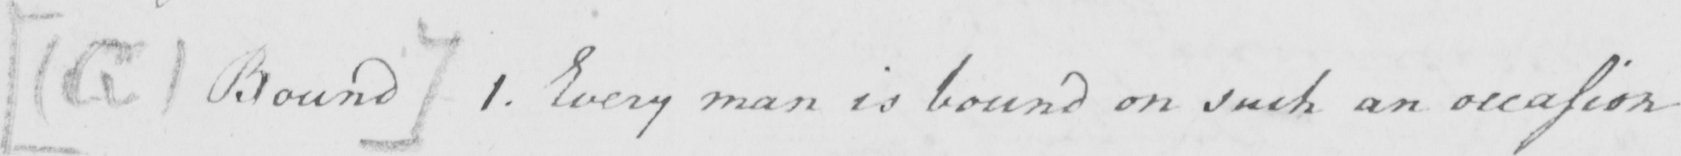Please provide the text content of this handwritten line. [ G Bound ]  1 . Everyman is bound on such an occasion 